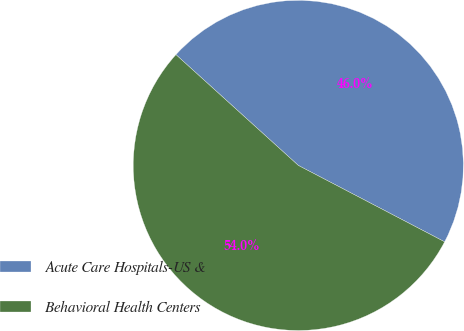<chart> <loc_0><loc_0><loc_500><loc_500><pie_chart><fcel>Acute Care Hospitals-US &<fcel>Behavioral Health Centers<nl><fcel>45.95%<fcel>54.05%<nl></chart> 